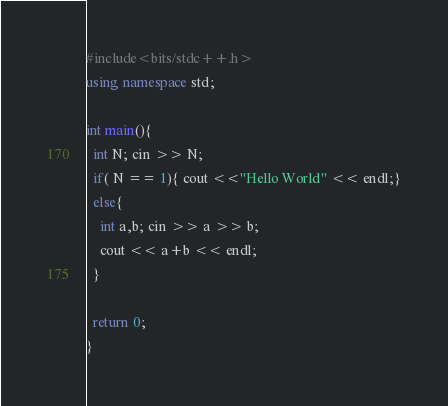Convert code to text. <code><loc_0><loc_0><loc_500><loc_500><_C++_>#include<bits/stdc++.h>
using namespace std;

int main(){
  int N; cin >> N;
  if( N == 1){ cout <<"Hello World" << endl;}
  else{
    int a,b; cin >> a >> b;
    cout << a+b << endl;
  }
  
  return 0;
}</code> 